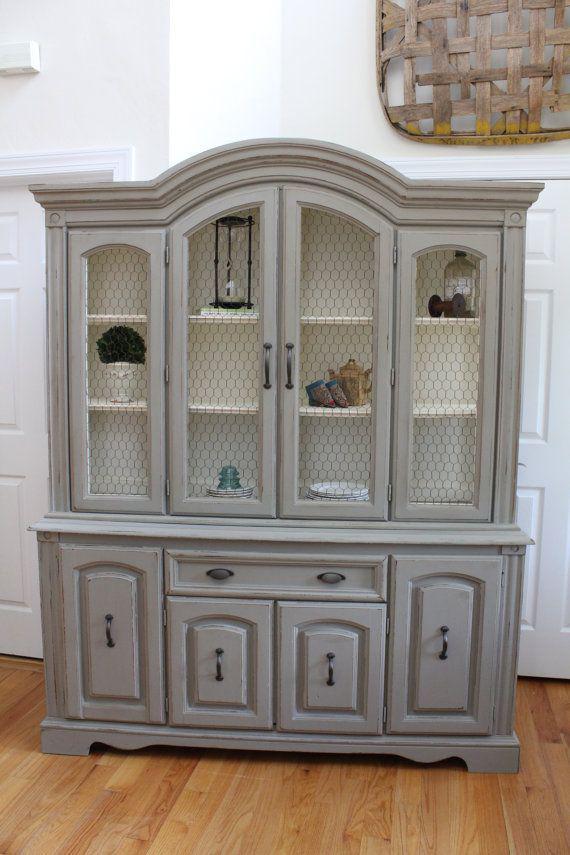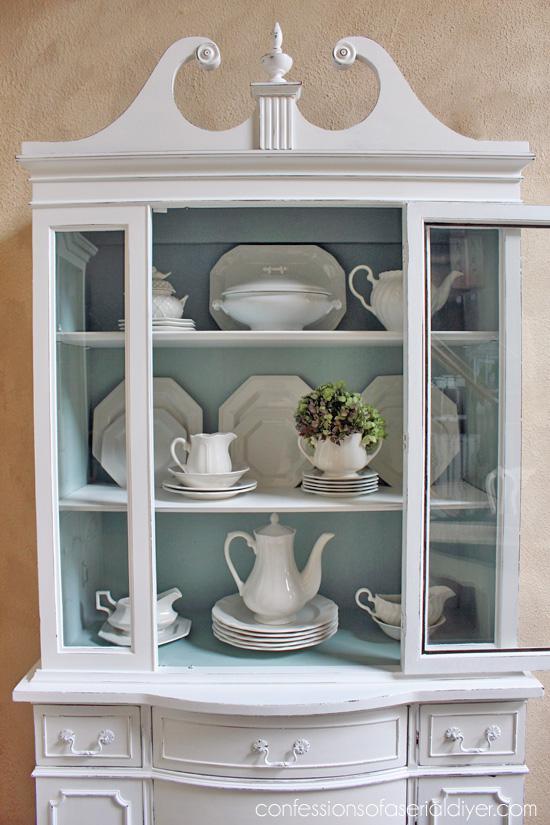The first image is the image on the left, the second image is the image on the right. Considering the images on both sides, is "There are cabinets with rounded tops" valid? Answer yes or no. Yes. 